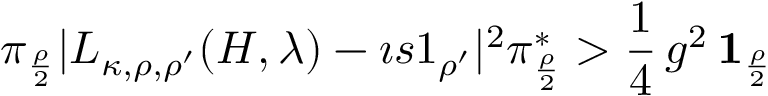<formula> <loc_0><loc_0><loc_500><loc_500>\pi _ { \frac { \rho } { 2 } } | L _ { \kappa , \rho , \rho ^ { \prime } } ( H , \lambda ) - \imath s 1 _ { \rho ^ { \prime } } | ^ { 2 } \pi _ { \frac { \rho } { 2 } } ^ { * } > \frac { 1 } { 4 } \, g ^ { 2 } \, { 1 } _ { \frac { \rho } { 2 } }</formula> 